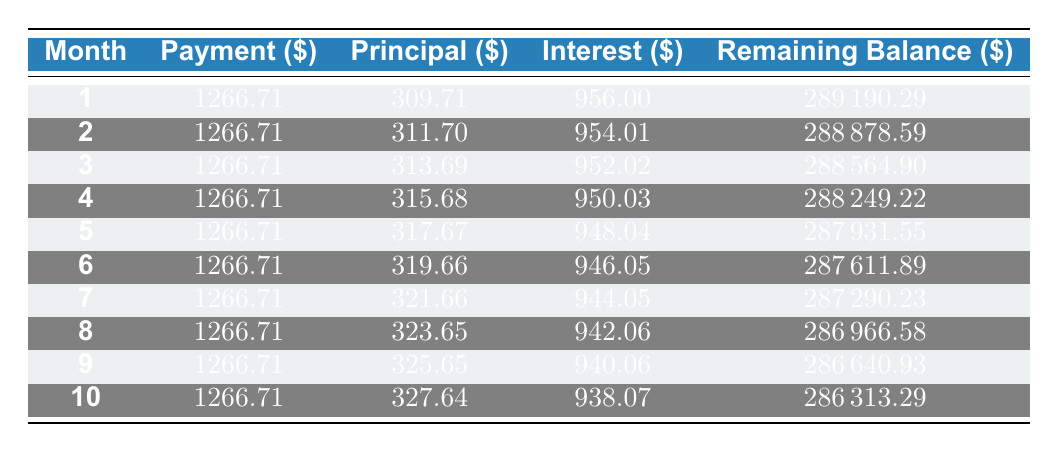What is the monthly payment amount for the loan? The table shows that the monthly payment amount is constant at 1266.71 across all months.
Answer: 1266.71 What is the principal paid in the first month? Referring to the first row of the table, the principal amount in the first month is 309.71.
Answer: 309.71 How much interest is paid in the second month? Looking at the second row of the table, the interest paid in the second month is 954.01.
Answer: 954.01 What is the total amount of principal paid in the first three months? The principal payments for the first three months are 309.71, 311.70, and 313.69, respectively. Summing these values gives: 309.71 + 311.70 + 313.69 = 935.10.
Answer: 935.10 Is the interest payment higher or lower than the principal payment in the first month? In the first month, the principal payment is 309.71 and the interest payment is 956.00. Since 956.00 is greater than 309.71, the interest payment is higher.
Answer: Yes What is the remaining balance after the third month? Referring to the third month in the table, the remaining balance is 288564.90.
Answer: 288564.90 How much total interest is paid in the first five months combined? To find the total interest for the first five months, sum the interest amounts: 956.00 + 954.01 + 952.02 + 950.03 + 948.04, which equals 4860.10.
Answer: 4860.10 Is the principal payment increasing, decreasing, or remaining constant over the months shown? Observing the principal payments from month 1 to month 10, they are increasing: 309.71, 311.70, 313.69, ... Continuing this pattern shows that the principal payment is on an upward trend.
Answer: Increasing What is the difference in interest payment between the first and tenth months? The interest payment in the first month is 956.00 and in the tenth month it is 938.07. The difference is calculated as 956.00 - 938.07 = 17.93.
Answer: 17.93 How much is the remaining balance reduced from the first month to the fifth month? The remaining balance after the first month is 289190.29 and after the fifth month is 287931.55. The reduction is calculated by 289190.29 - 287931.55 = 1258.74.
Answer: 1258.74 